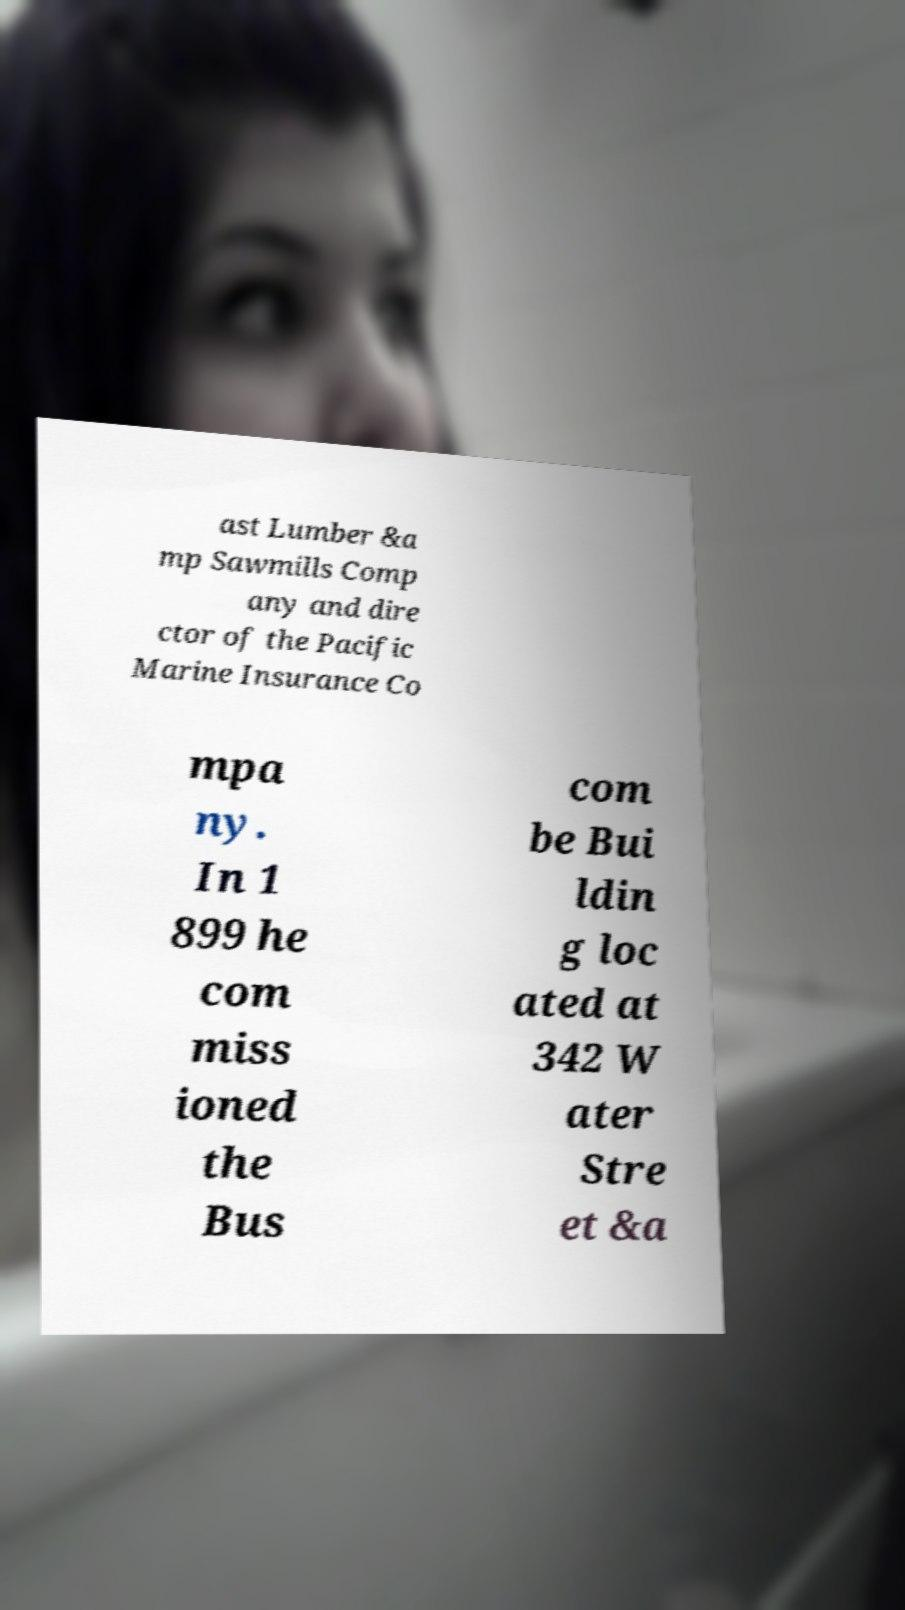For documentation purposes, I need the text within this image transcribed. Could you provide that? ast Lumber &a mp Sawmills Comp any and dire ctor of the Pacific Marine Insurance Co mpa ny. In 1 899 he com miss ioned the Bus com be Bui ldin g loc ated at 342 W ater Stre et &a 